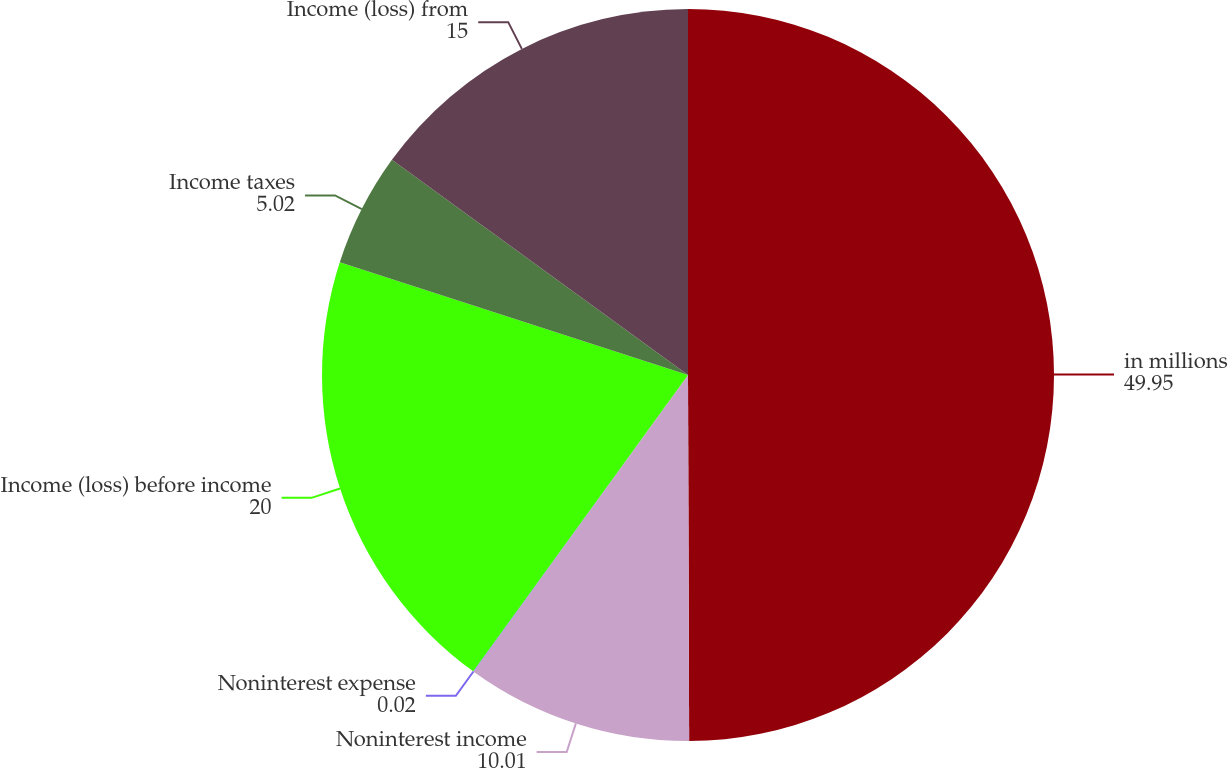Convert chart. <chart><loc_0><loc_0><loc_500><loc_500><pie_chart><fcel>in millions<fcel>Noninterest income<fcel>Noninterest expense<fcel>Income (loss) before income<fcel>Income taxes<fcel>Income (loss) from<nl><fcel>49.95%<fcel>10.01%<fcel>0.02%<fcel>20.0%<fcel>5.02%<fcel>15.0%<nl></chart> 